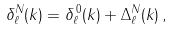<formula> <loc_0><loc_0><loc_500><loc_500>\delta ^ { N } _ { \ell } ( k ) = \delta ^ { \, 0 } _ { \ell } ( k ) + \Delta ^ { N } _ { \ell } ( k ) \, ,</formula> 